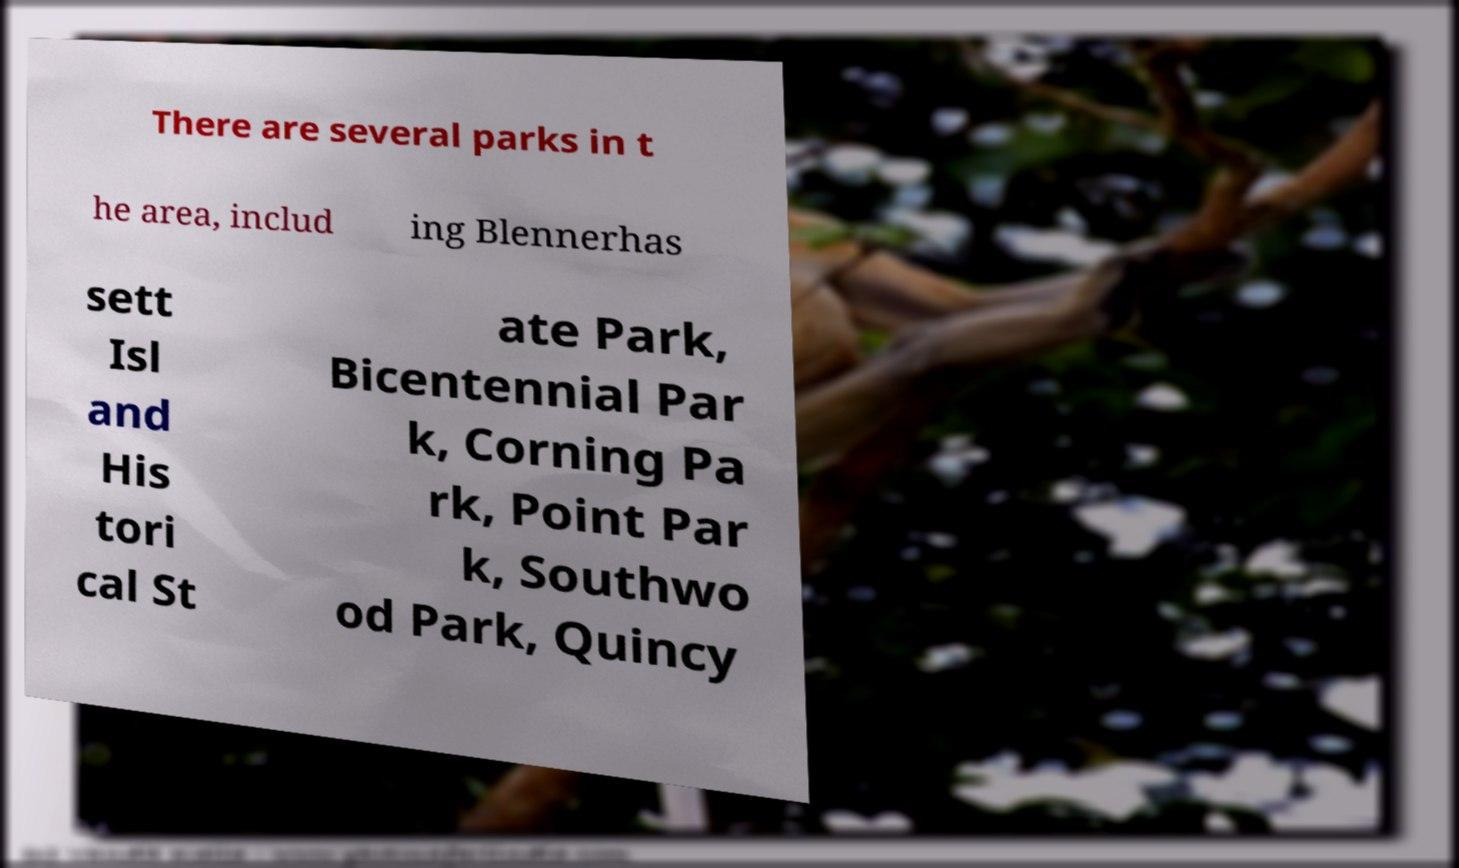I need the written content from this picture converted into text. Can you do that? There are several parks in t he area, includ ing Blennerhas sett Isl and His tori cal St ate Park, Bicentennial Par k, Corning Pa rk, Point Par k, Southwo od Park, Quincy 